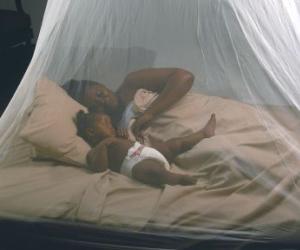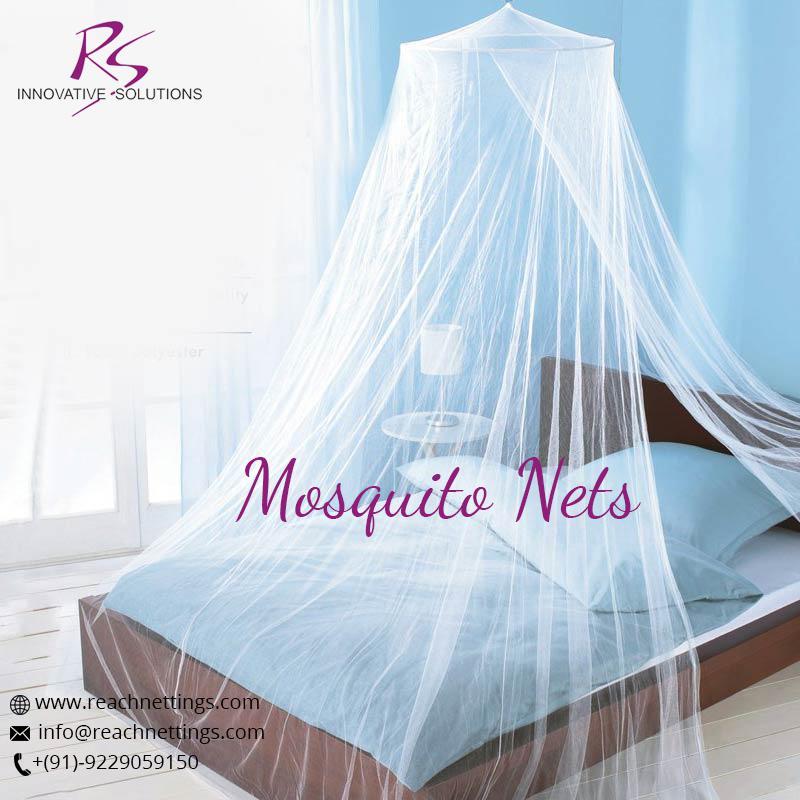The first image is the image on the left, the second image is the image on the right. Given the left and right images, does the statement "The right net/drape has a cone on the top." hold true? Answer yes or no. Yes. The first image is the image on the left, the second image is the image on the right. Considering the images on both sides, is "There are  two canopies that white beds and at least one is square." valid? Answer yes or no. No. 